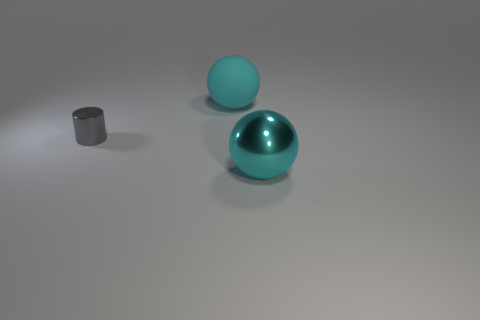How many cyan balls must be subtracted to get 1 cyan balls? 1 Add 1 cyan shiny balls. How many objects exist? 4 Subtract all cylinders. How many objects are left? 2 Add 1 large objects. How many large objects exist? 3 Subtract 0 gray balls. How many objects are left? 3 Subtract all large cyan shiny things. Subtract all cyan shiny objects. How many objects are left? 1 Add 3 cyan metal spheres. How many cyan metal spheres are left? 4 